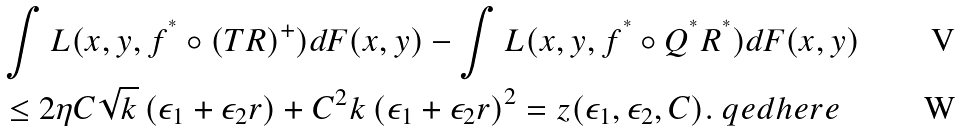Convert formula to latex. <formula><loc_0><loc_0><loc_500><loc_500>& \int L ( x , y , f ^ { ^ { * } } \circ ( T R ) ^ { + } ) d F ( x , y ) - \int L ( x , y , f ^ { ^ { * } } \circ Q ^ { ^ { * } } R ^ { ^ { * } } ) d F ( x , y ) \\ & \leq 2 \eta C \sqrt { k } \left ( \epsilon _ { 1 } + \epsilon _ { 2 } r \right ) + C ^ { 2 } k \left ( \epsilon _ { 1 } + \epsilon _ { 2 } r \right ) ^ { 2 } = z ( \epsilon _ { 1 } , \epsilon _ { 2 } , C ) . \ q e d h e r e</formula> 